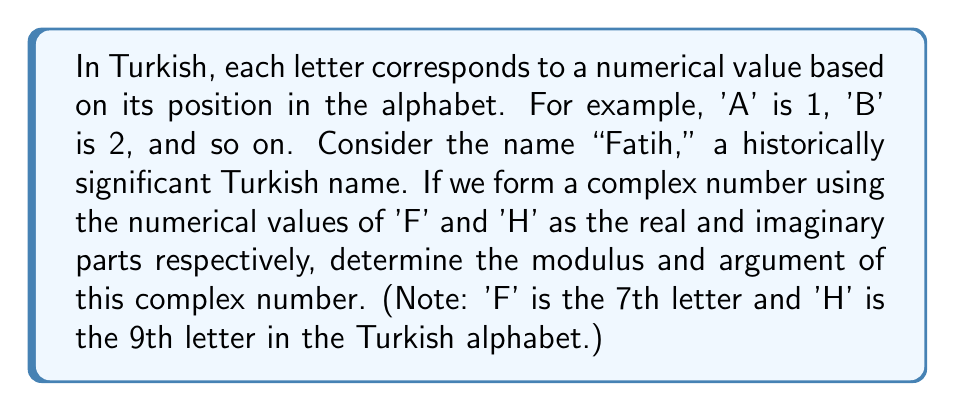What is the answer to this math problem? Let's approach this step-by-step:

1) First, we need to form the complex number:
   'F' is the 7th letter, so its value is 7 (real part)
   'H' is the 9th letter, so its value is 9 (imaginary part)
   
   The complex number is thus: $z = 7 + 9i$

2) To find the modulus, we use the formula: $|z| = \sqrt{a^2 + b^2}$, where $a$ is the real part and $b$ is the imaginary part.

   $|z| = \sqrt{7^2 + 9^2} = \sqrt{49 + 81} = \sqrt{130}$

3) To find the argument, we use the formula: $\arg(z) = \tan^{-1}(\frac{b}{a})$, where $a$ is the real part and $b$ is the imaginary part.

   $\arg(z) = \tan^{-1}(\frac{9}{7})$

4) Converting the argument to degrees:
   $\arg(z) = \tan^{-1}(\frac{9}{7}) \approx 52.13^\circ$

Therefore, the modulus is $\sqrt{130}$ and the argument is approximately $52.13^\circ$.
Answer: Modulus: $\sqrt{130}$, Argument: $52.13^\circ$ 